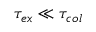Convert formula to latex. <formula><loc_0><loc_0><loc_500><loc_500>\tau _ { e x } \ll \tau _ { c o l }</formula> 